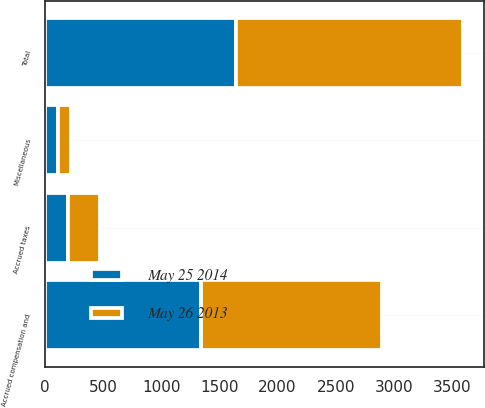<chart> <loc_0><loc_0><loc_500><loc_500><stacked_bar_chart><ecel><fcel>Accrued compensation and<fcel>Accrued taxes<fcel>Miscellaneous<fcel>Total<nl><fcel>May 25 2014<fcel>1341.9<fcel>195.6<fcel>105.7<fcel>1643.2<nl><fcel>May 26 2013<fcel>1560.2<fcel>277.1<fcel>115.6<fcel>1952.9<nl></chart> 